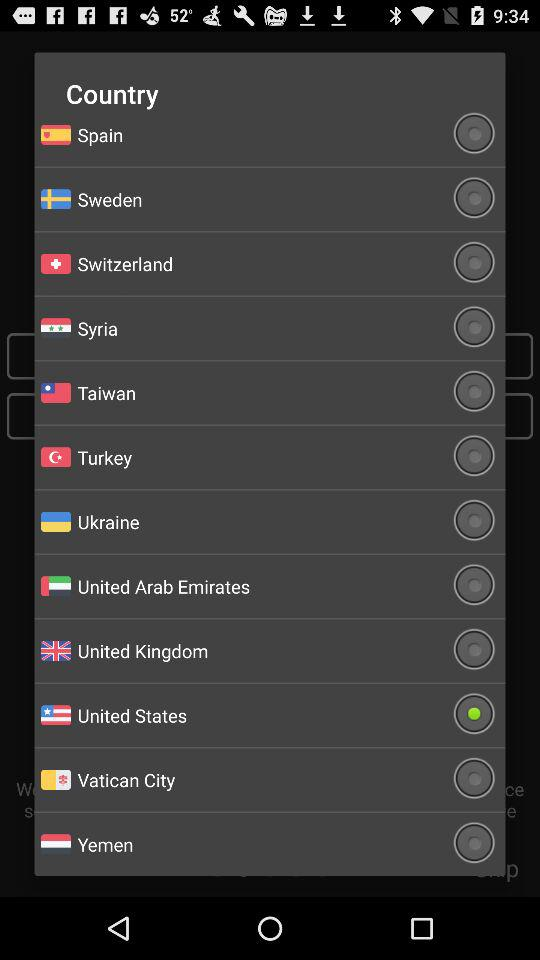What is the name of the application?
When the provided information is insufficient, respond with <no answer>. <no answer> 